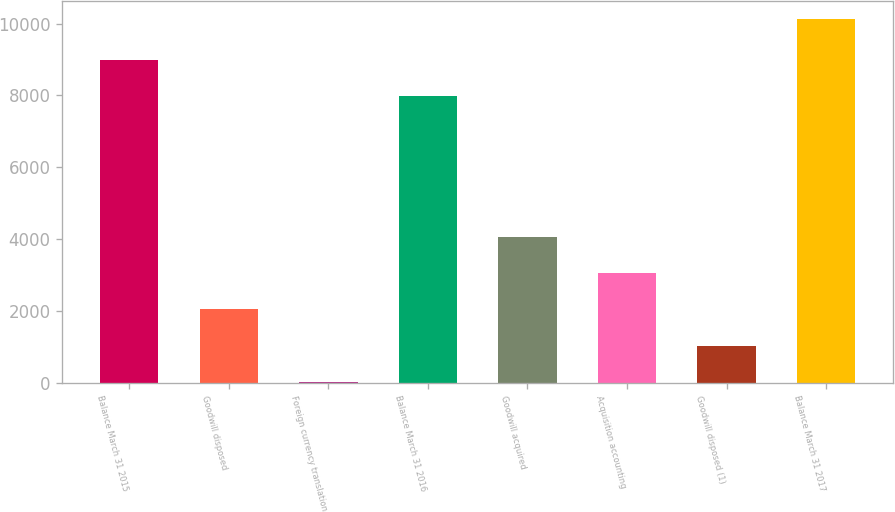Convert chart. <chart><loc_0><loc_0><loc_500><loc_500><bar_chart><fcel>Balance March 31 2015<fcel>Goodwill disposed<fcel>Foreign currency translation<fcel>Balance March 31 2016<fcel>Goodwill acquired<fcel>Acquisition accounting<fcel>Goodwill disposed (1)<fcel>Balance March 31 2017<nl><fcel>8997.9<fcel>2044.8<fcel>23<fcel>7987<fcel>4066.6<fcel>3055.7<fcel>1033.9<fcel>10132<nl></chart> 